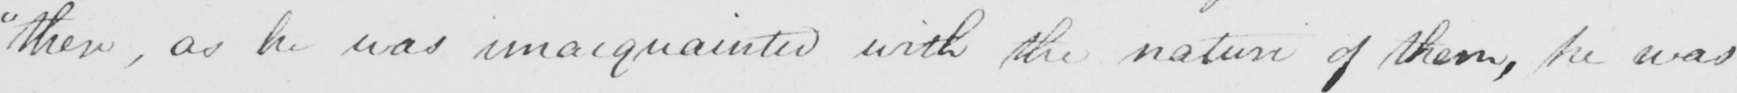What is written in this line of handwriting? " then , as he was unacquainted with the nature of them , he was 